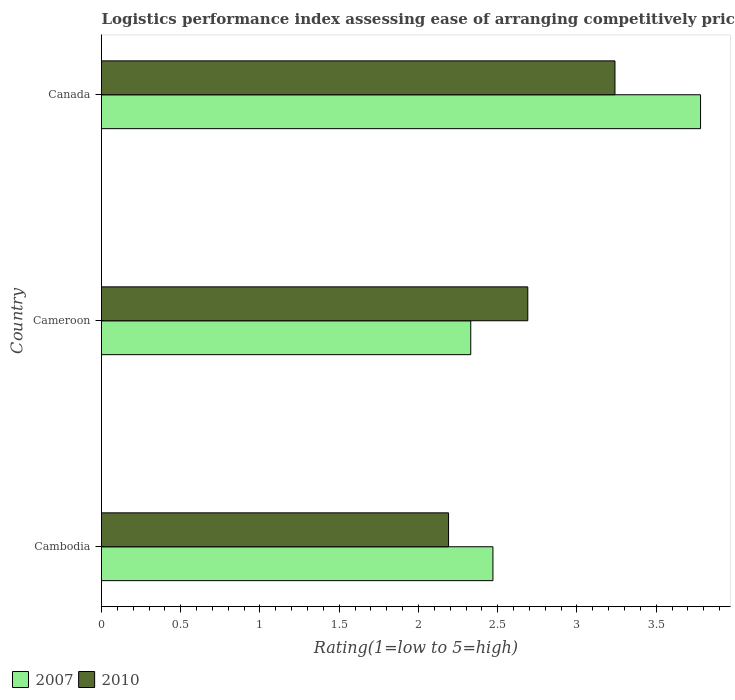How many different coloured bars are there?
Provide a succinct answer. 2. Are the number of bars on each tick of the Y-axis equal?
Your response must be concise. Yes. What is the label of the 2nd group of bars from the top?
Give a very brief answer. Cameroon. In how many cases, is the number of bars for a given country not equal to the number of legend labels?
Keep it short and to the point. 0. What is the Logistic performance index in 2010 in Canada?
Provide a succinct answer. 3.24. Across all countries, what is the maximum Logistic performance index in 2007?
Make the answer very short. 3.78. Across all countries, what is the minimum Logistic performance index in 2007?
Your answer should be very brief. 2.33. In which country was the Logistic performance index in 2007 maximum?
Offer a terse response. Canada. In which country was the Logistic performance index in 2007 minimum?
Your answer should be very brief. Cameroon. What is the total Logistic performance index in 2010 in the graph?
Offer a terse response. 8.12. What is the difference between the Logistic performance index in 2010 in Cameroon and that in Canada?
Give a very brief answer. -0.55. What is the difference between the Logistic performance index in 2007 in Cambodia and the Logistic performance index in 2010 in Canada?
Provide a short and direct response. -0.77. What is the average Logistic performance index in 2007 per country?
Your response must be concise. 2.86. What is the difference between the Logistic performance index in 2007 and Logistic performance index in 2010 in Cameroon?
Your answer should be very brief. -0.36. What is the ratio of the Logistic performance index in 2010 in Cameroon to that in Canada?
Provide a succinct answer. 0.83. Is the difference between the Logistic performance index in 2007 in Cameroon and Canada greater than the difference between the Logistic performance index in 2010 in Cameroon and Canada?
Provide a succinct answer. No. What is the difference between the highest and the second highest Logistic performance index in 2010?
Your answer should be very brief. 0.55. What is the difference between the highest and the lowest Logistic performance index in 2007?
Your response must be concise. 1.45. What does the 2nd bar from the top in Cambodia represents?
Give a very brief answer. 2007. What does the 1st bar from the bottom in Cameroon represents?
Your answer should be compact. 2007. What is the difference between two consecutive major ticks on the X-axis?
Keep it short and to the point. 0.5. Are the values on the major ticks of X-axis written in scientific E-notation?
Provide a short and direct response. No. Does the graph contain grids?
Make the answer very short. No. What is the title of the graph?
Make the answer very short. Logistics performance index assessing ease of arranging competitively priced shipments to markets. Does "1978" appear as one of the legend labels in the graph?
Your response must be concise. No. What is the label or title of the X-axis?
Make the answer very short. Rating(1=low to 5=high). What is the Rating(1=low to 5=high) of 2007 in Cambodia?
Give a very brief answer. 2.47. What is the Rating(1=low to 5=high) in 2010 in Cambodia?
Provide a short and direct response. 2.19. What is the Rating(1=low to 5=high) of 2007 in Cameroon?
Your answer should be compact. 2.33. What is the Rating(1=low to 5=high) of 2010 in Cameroon?
Offer a terse response. 2.69. What is the Rating(1=low to 5=high) in 2007 in Canada?
Offer a very short reply. 3.78. What is the Rating(1=low to 5=high) of 2010 in Canada?
Provide a succinct answer. 3.24. Across all countries, what is the maximum Rating(1=low to 5=high) of 2007?
Give a very brief answer. 3.78. Across all countries, what is the maximum Rating(1=low to 5=high) in 2010?
Your answer should be compact. 3.24. Across all countries, what is the minimum Rating(1=low to 5=high) of 2007?
Offer a very short reply. 2.33. Across all countries, what is the minimum Rating(1=low to 5=high) in 2010?
Give a very brief answer. 2.19. What is the total Rating(1=low to 5=high) of 2007 in the graph?
Keep it short and to the point. 8.58. What is the total Rating(1=low to 5=high) of 2010 in the graph?
Your answer should be compact. 8.12. What is the difference between the Rating(1=low to 5=high) of 2007 in Cambodia and that in Cameroon?
Your response must be concise. 0.14. What is the difference between the Rating(1=low to 5=high) in 2010 in Cambodia and that in Cameroon?
Provide a succinct answer. -0.5. What is the difference between the Rating(1=low to 5=high) in 2007 in Cambodia and that in Canada?
Your answer should be compact. -1.31. What is the difference between the Rating(1=low to 5=high) in 2010 in Cambodia and that in Canada?
Offer a terse response. -1.05. What is the difference between the Rating(1=low to 5=high) of 2007 in Cameroon and that in Canada?
Keep it short and to the point. -1.45. What is the difference between the Rating(1=low to 5=high) of 2010 in Cameroon and that in Canada?
Offer a very short reply. -0.55. What is the difference between the Rating(1=low to 5=high) in 2007 in Cambodia and the Rating(1=low to 5=high) in 2010 in Cameroon?
Make the answer very short. -0.22. What is the difference between the Rating(1=low to 5=high) in 2007 in Cambodia and the Rating(1=low to 5=high) in 2010 in Canada?
Give a very brief answer. -0.77. What is the difference between the Rating(1=low to 5=high) in 2007 in Cameroon and the Rating(1=low to 5=high) in 2010 in Canada?
Your answer should be compact. -0.91. What is the average Rating(1=low to 5=high) in 2007 per country?
Provide a short and direct response. 2.86. What is the average Rating(1=low to 5=high) in 2010 per country?
Your response must be concise. 2.71. What is the difference between the Rating(1=low to 5=high) of 2007 and Rating(1=low to 5=high) of 2010 in Cambodia?
Keep it short and to the point. 0.28. What is the difference between the Rating(1=low to 5=high) of 2007 and Rating(1=low to 5=high) of 2010 in Cameroon?
Provide a short and direct response. -0.36. What is the difference between the Rating(1=low to 5=high) of 2007 and Rating(1=low to 5=high) of 2010 in Canada?
Your answer should be very brief. 0.54. What is the ratio of the Rating(1=low to 5=high) of 2007 in Cambodia to that in Cameroon?
Keep it short and to the point. 1.06. What is the ratio of the Rating(1=low to 5=high) of 2010 in Cambodia to that in Cameroon?
Your response must be concise. 0.81. What is the ratio of the Rating(1=low to 5=high) of 2007 in Cambodia to that in Canada?
Make the answer very short. 0.65. What is the ratio of the Rating(1=low to 5=high) in 2010 in Cambodia to that in Canada?
Your response must be concise. 0.68. What is the ratio of the Rating(1=low to 5=high) of 2007 in Cameroon to that in Canada?
Your answer should be very brief. 0.62. What is the ratio of the Rating(1=low to 5=high) of 2010 in Cameroon to that in Canada?
Give a very brief answer. 0.83. What is the difference between the highest and the second highest Rating(1=low to 5=high) in 2007?
Provide a succinct answer. 1.31. What is the difference between the highest and the second highest Rating(1=low to 5=high) in 2010?
Offer a very short reply. 0.55. What is the difference between the highest and the lowest Rating(1=low to 5=high) of 2007?
Provide a short and direct response. 1.45. What is the difference between the highest and the lowest Rating(1=low to 5=high) in 2010?
Ensure brevity in your answer.  1.05. 